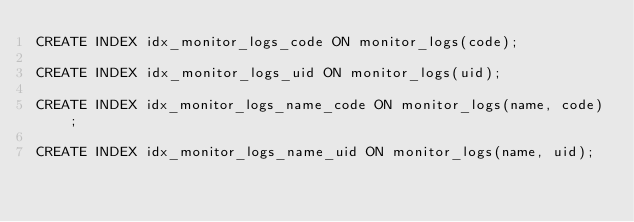Convert code to text. <code><loc_0><loc_0><loc_500><loc_500><_SQL_>CREATE INDEX idx_monitor_logs_code ON monitor_logs(code);

CREATE INDEX idx_monitor_logs_uid ON monitor_logs(uid);

CREATE INDEX idx_monitor_logs_name_code ON monitor_logs(name, code);

CREATE INDEX idx_monitor_logs_name_uid ON monitor_logs(name, uid);</code> 